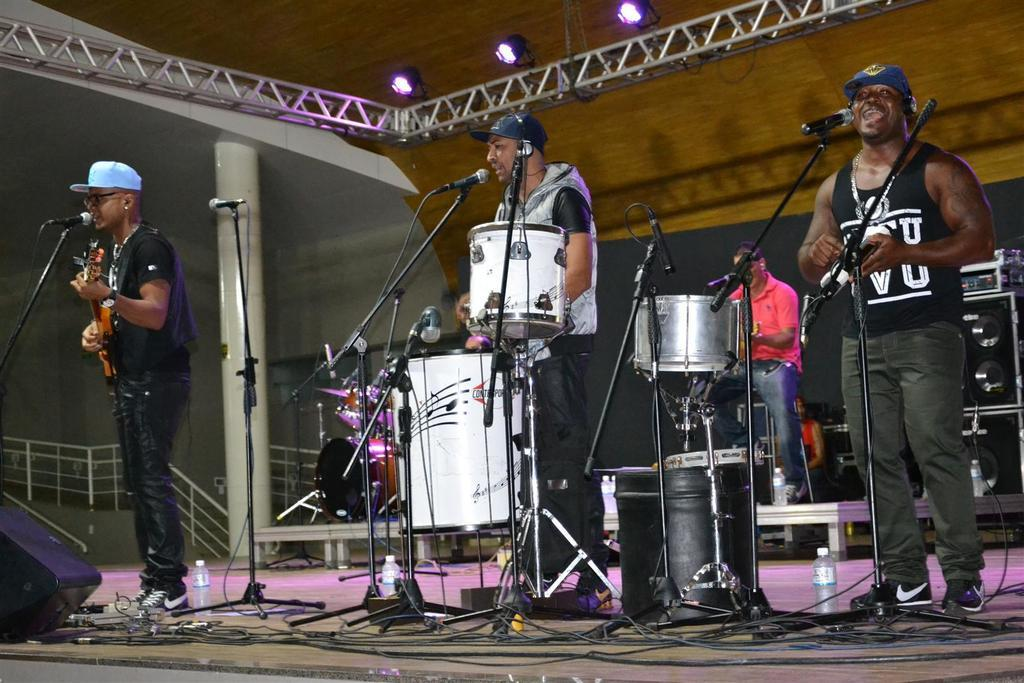What type of people are in the image? There is a group of people in the image, and they are musicians. What are the musicians doing in the image? The musicians are playing instruments. Can you describe any equipment used by the musicians in the image? There is a microphone in the image, which is commonly used for amplifying sound. What items might be used for hydration in the image? Water bottles are visible in the image. What type of objects are present in the image that might be used for support or structure? Metal rods are present in the image. What type of lighting is present in the image? Lights are present in the image. What type of sea creatures can be seen swimming in the image? There are no sea creatures present in the image; it features a group of musicians playing instruments. How does the concept of love influence the music being played in the image? The image does not provide any information about the music being played or the influence of love on it. 